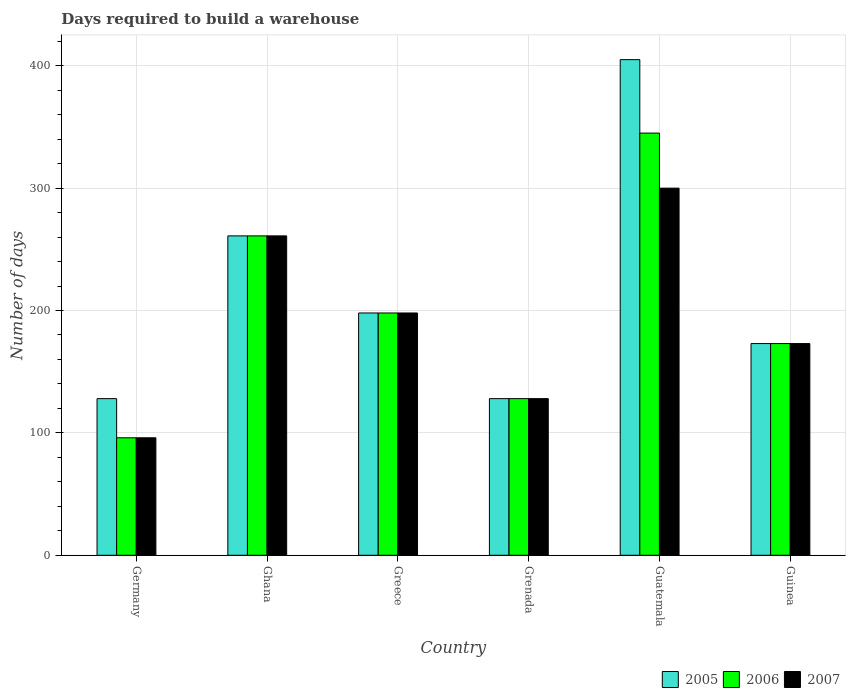How many different coloured bars are there?
Provide a succinct answer. 3. How many groups of bars are there?
Provide a short and direct response. 6. Are the number of bars on each tick of the X-axis equal?
Provide a short and direct response. Yes. How many bars are there on the 3rd tick from the left?
Provide a succinct answer. 3. How many bars are there on the 3rd tick from the right?
Ensure brevity in your answer.  3. What is the label of the 1st group of bars from the left?
Offer a terse response. Germany. In how many cases, is the number of bars for a given country not equal to the number of legend labels?
Ensure brevity in your answer.  0. What is the days required to build a warehouse in in 2006 in Greece?
Provide a succinct answer. 198. Across all countries, what is the maximum days required to build a warehouse in in 2005?
Your answer should be very brief. 405. Across all countries, what is the minimum days required to build a warehouse in in 2006?
Offer a very short reply. 96. In which country was the days required to build a warehouse in in 2006 maximum?
Give a very brief answer. Guatemala. What is the total days required to build a warehouse in in 2005 in the graph?
Make the answer very short. 1293. What is the difference between the days required to build a warehouse in in 2005 in Germany and that in Greece?
Offer a terse response. -70. What is the difference between the days required to build a warehouse in in 2005 in Grenada and the days required to build a warehouse in in 2006 in Greece?
Ensure brevity in your answer.  -70. What is the average days required to build a warehouse in in 2005 per country?
Offer a terse response. 215.5. What is the difference between the days required to build a warehouse in of/in 2007 and days required to build a warehouse in of/in 2006 in Ghana?
Offer a very short reply. 0. What is the ratio of the days required to build a warehouse in in 2006 in Ghana to that in Grenada?
Make the answer very short. 2.04. Is the difference between the days required to build a warehouse in in 2007 in Ghana and Grenada greater than the difference between the days required to build a warehouse in in 2006 in Ghana and Grenada?
Offer a very short reply. No. What is the difference between the highest and the lowest days required to build a warehouse in in 2006?
Your response must be concise. 249. In how many countries, is the days required to build a warehouse in in 2005 greater than the average days required to build a warehouse in in 2005 taken over all countries?
Offer a terse response. 2. Are all the bars in the graph horizontal?
Give a very brief answer. No. What is the difference between two consecutive major ticks on the Y-axis?
Give a very brief answer. 100. Are the values on the major ticks of Y-axis written in scientific E-notation?
Your answer should be compact. No. Does the graph contain any zero values?
Provide a short and direct response. No. How many legend labels are there?
Provide a short and direct response. 3. How are the legend labels stacked?
Your answer should be very brief. Horizontal. What is the title of the graph?
Give a very brief answer. Days required to build a warehouse. What is the label or title of the X-axis?
Make the answer very short. Country. What is the label or title of the Y-axis?
Provide a succinct answer. Number of days. What is the Number of days of 2005 in Germany?
Make the answer very short. 128. What is the Number of days of 2006 in Germany?
Keep it short and to the point. 96. What is the Number of days of 2007 in Germany?
Provide a short and direct response. 96. What is the Number of days of 2005 in Ghana?
Give a very brief answer. 261. What is the Number of days of 2006 in Ghana?
Offer a terse response. 261. What is the Number of days in 2007 in Ghana?
Your response must be concise. 261. What is the Number of days in 2005 in Greece?
Ensure brevity in your answer.  198. What is the Number of days in 2006 in Greece?
Your answer should be very brief. 198. What is the Number of days of 2007 in Greece?
Provide a succinct answer. 198. What is the Number of days of 2005 in Grenada?
Provide a succinct answer. 128. What is the Number of days of 2006 in Grenada?
Your answer should be very brief. 128. What is the Number of days in 2007 in Grenada?
Keep it short and to the point. 128. What is the Number of days in 2005 in Guatemala?
Offer a very short reply. 405. What is the Number of days in 2006 in Guatemala?
Make the answer very short. 345. What is the Number of days of 2007 in Guatemala?
Offer a very short reply. 300. What is the Number of days in 2005 in Guinea?
Make the answer very short. 173. What is the Number of days in 2006 in Guinea?
Provide a succinct answer. 173. What is the Number of days of 2007 in Guinea?
Keep it short and to the point. 173. Across all countries, what is the maximum Number of days in 2005?
Your answer should be compact. 405. Across all countries, what is the maximum Number of days in 2006?
Your response must be concise. 345. Across all countries, what is the maximum Number of days in 2007?
Provide a short and direct response. 300. Across all countries, what is the minimum Number of days in 2005?
Keep it short and to the point. 128. Across all countries, what is the minimum Number of days of 2006?
Keep it short and to the point. 96. Across all countries, what is the minimum Number of days of 2007?
Provide a succinct answer. 96. What is the total Number of days in 2005 in the graph?
Your response must be concise. 1293. What is the total Number of days of 2006 in the graph?
Your answer should be very brief. 1201. What is the total Number of days of 2007 in the graph?
Ensure brevity in your answer.  1156. What is the difference between the Number of days of 2005 in Germany and that in Ghana?
Offer a very short reply. -133. What is the difference between the Number of days of 2006 in Germany and that in Ghana?
Your response must be concise. -165. What is the difference between the Number of days of 2007 in Germany and that in Ghana?
Provide a succinct answer. -165. What is the difference between the Number of days in 2005 in Germany and that in Greece?
Provide a short and direct response. -70. What is the difference between the Number of days of 2006 in Germany and that in Greece?
Make the answer very short. -102. What is the difference between the Number of days of 2007 in Germany and that in Greece?
Provide a succinct answer. -102. What is the difference between the Number of days of 2006 in Germany and that in Grenada?
Provide a short and direct response. -32. What is the difference between the Number of days in 2007 in Germany and that in Grenada?
Offer a very short reply. -32. What is the difference between the Number of days of 2005 in Germany and that in Guatemala?
Provide a succinct answer. -277. What is the difference between the Number of days in 2006 in Germany and that in Guatemala?
Offer a very short reply. -249. What is the difference between the Number of days of 2007 in Germany and that in Guatemala?
Offer a very short reply. -204. What is the difference between the Number of days in 2005 in Germany and that in Guinea?
Your response must be concise. -45. What is the difference between the Number of days of 2006 in Germany and that in Guinea?
Make the answer very short. -77. What is the difference between the Number of days in 2007 in Germany and that in Guinea?
Give a very brief answer. -77. What is the difference between the Number of days of 2005 in Ghana and that in Greece?
Your response must be concise. 63. What is the difference between the Number of days of 2006 in Ghana and that in Greece?
Provide a short and direct response. 63. What is the difference between the Number of days of 2007 in Ghana and that in Greece?
Ensure brevity in your answer.  63. What is the difference between the Number of days of 2005 in Ghana and that in Grenada?
Your response must be concise. 133. What is the difference between the Number of days in 2006 in Ghana and that in Grenada?
Provide a short and direct response. 133. What is the difference between the Number of days of 2007 in Ghana and that in Grenada?
Your response must be concise. 133. What is the difference between the Number of days in 2005 in Ghana and that in Guatemala?
Your answer should be very brief. -144. What is the difference between the Number of days in 2006 in Ghana and that in Guatemala?
Provide a succinct answer. -84. What is the difference between the Number of days of 2007 in Ghana and that in Guatemala?
Offer a very short reply. -39. What is the difference between the Number of days in 2005 in Ghana and that in Guinea?
Provide a short and direct response. 88. What is the difference between the Number of days in 2006 in Ghana and that in Guinea?
Offer a very short reply. 88. What is the difference between the Number of days in 2007 in Ghana and that in Guinea?
Your answer should be very brief. 88. What is the difference between the Number of days of 2006 in Greece and that in Grenada?
Give a very brief answer. 70. What is the difference between the Number of days of 2007 in Greece and that in Grenada?
Provide a succinct answer. 70. What is the difference between the Number of days in 2005 in Greece and that in Guatemala?
Give a very brief answer. -207. What is the difference between the Number of days of 2006 in Greece and that in Guatemala?
Offer a very short reply. -147. What is the difference between the Number of days in 2007 in Greece and that in Guatemala?
Keep it short and to the point. -102. What is the difference between the Number of days of 2007 in Greece and that in Guinea?
Your answer should be compact. 25. What is the difference between the Number of days in 2005 in Grenada and that in Guatemala?
Provide a succinct answer. -277. What is the difference between the Number of days of 2006 in Grenada and that in Guatemala?
Your response must be concise. -217. What is the difference between the Number of days in 2007 in Grenada and that in Guatemala?
Provide a succinct answer. -172. What is the difference between the Number of days of 2005 in Grenada and that in Guinea?
Your response must be concise. -45. What is the difference between the Number of days in 2006 in Grenada and that in Guinea?
Ensure brevity in your answer.  -45. What is the difference between the Number of days of 2007 in Grenada and that in Guinea?
Keep it short and to the point. -45. What is the difference between the Number of days in 2005 in Guatemala and that in Guinea?
Provide a short and direct response. 232. What is the difference between the Number of days in 2006 in Guatemala and that in Guinea?
Give a very brief answer. 172. What is the difference between the Number of days of 2007 in Guatemala and that in Guinea?
Your answer should be compact. 127. What is the difference between the Number of days of 2005 in Germany and the Number of days of 2006 in Ghana?
Your answer should be very brief. -133. What is the difference between the Number of days in 2005 in Germany and the Number of days in 2007 in Ghana?
Keep it short and to the point. -133. What is the difference between the Number of days in 2006 in Germany and the Number of days in 2007 in Ghana?
Give a very brief answer. -165. What is the difference between the Number of days of 2005 in Germany and the Number of days of 2006 in Greece?
Your answer should be compact. -70. What is the difference between the Number of days in 2005 in Germany and the Number of days in 2007 in Greece?
Provide a succinct answer. -70. What is the difference between the Number of days of 2006 in Germany and the Number of days of 2007 in Greece?
Give a very brief answer. -102. What is the difference between the Number of days in 2006 in Germany and the Number of days in 2007 in Grenada?
Ensure brevity in your answer.  -32. What is the difference between the Number of days in 2005 in Germany and the Number of days in 2006 in Guatemala?
Provide a short and direct response. -217. What is the difference between the Number of days of 2005 in Germany and the Number of days of 2007 in Guatemala?
Your answer should be very brief. -172. What is the difference between the Number of days of 2006 in Germany and the Number of days of 2007 in Guatemala?
Give a very brief answer. -204. What is the difference between the Number of days in 2005 in Germany and the Number of days in 2006 in Guinea?
Ensure brevity in your answer.  -45. What is the difference between the Number of days of 2005 in Germany and the Number of days of 2007 in Guinea?
Offer a terse response. -45. What is the difference between the Number of days of 2006 in Germany and the Number of days of 2007 in Guinea?
Make the answer very short. -77. What is the difference between the Number of days in 2005 in Ghana and the Number of days in 2006 in Greece?
Ensure brevity in your answer.  63. What is the difference between the Number of days in 2005 in Ghana and the Number of days in 2007 in Greece?
Ensure brevity in your answer.  63. What is the difference between the Number of days in 2005 in Ghana and the Number of days in 2006 in Grenada?
Provide a succinct answer. 133. What is the difference between the Number of days of 2005 in Ghana and the Number of days of 2007 in Grenada?
Your response must be concise. 133. What is the difference between the Number of days of 2006 in Ghana and the Number of days of 2007 in Grenada?
Give a very brief answer. 133. What is the difference between the Number of days of 2005 in Ghana and the Number of days of 2006 in Guatemala?
Keep it short and to the point. -84. What is the difference between the Number of days in 2005 in Ghana and the Number of days in 2007 in Guatemala?
Offer a terse response. -39. What is the difference between the Number of days in 2006 in Ghana and the Number of days in 2007 in Guatemala?
Offer a terse response. -39. What is the difference between the Number of days of 2006 in Ghana and the Number of days of 2007 in Guinea?
Make the answer very short. 88. What is the difference between the Number of days of 2006 in Greece and the Number of days of 2007 in Grenada?
Keep it short and to the point. 70. What is the difference between the Number of days of 2005 in Greece and the Number of days of 2006 in Guatemala?
Your answer should be compact. -147. What is the difference between the Number of days of 2005 in Greece and the Number of days of 2007 in Guatemala?
Offer a terse response. -102. What is the difference between the Number of days in 2006 in Greece and the Number of days in 2007 in Guatemala?
Your response must be concise. -102. What is the difference between the Number of days of 2005 in Greece and the Number of days of 2006 in Guinea?
Ensure brevity in your answer.  25. What is the difference between the Number of days of 2005 in Greece and the Number of days of 2007 in Guinea?
Your answer should be very brief. 25. What is the difference between the Number of days of 2005 in Grenada and the Number of days of 2006 in Guatemala?
Your answer should be very brief. -217. What is the difference between the Number of days of 2005 in Grenada and the Number of days of 2007 in Guatemala?
Make the answer very short. -172. What is the difference between the Number of days of 2006 in Grenada and the Number of days of 2007 in Guatemala?
Provide a short and direct response. -172. What is the difference between the Number of days of 2005 in Grenada and the Number of days of 2006 in Guinea?
Keep it short and to the point. -45. What is the difference between the Number of days in 2005 in Grenada and the Number of days in 2007 in Guinea?
Offer a terse response. -45. What is the difference between the Number of days of 2006 in Grenada and the Number of days of 2007 in Guinea?
Your answer should be very brief. -45. What is the difference between the Number of days of 2005 in Guatemala and the Number of days of 2006 in Guinea?
Your answer should be compact. 232. What is the difference between the Number of days in 2005 in Guatemala and the Number of days in 2007 in Guinea?
Ensure brevity in your answer.  232. What is the difference between the Number of days of 2006 in Guatemala and the Number of days of 2007 in Guinea?
Your answer should be very brief. 172. What is the average Number of days of 2005 per country?
Keep it short and to the point. 215.5. What is the average Number of days of 2006 per country?
Offer a very short reply. 200.17. What is the average Number of days of 2007 per country?
Offer a very short reply. 192.67. What is the difference between the Number of days in 2006 and Number of days in 2007 in Germany?
Make the answer very short. 0. What is the difference between the Number of days of 2005 and Number of days of 2006 in Ghana?
Provide a succinct answer. 0. What is the difference between the Number of days of 2005 and Number of days of 2007 in Ghana?
Keep it short and to the point. 0. What is the difference between the Number of days in 2006 and Number of days in 2007 in Ghana?
Your response must be concise. 0. What is the difference between the Number of days in 2005 and Number of days in 2006 in Greece?
Your answer should be very brief. 0. What is the difference between the Number of days of 2006 and Number of days of 2007 in Greece?
Your answer should be compact. 0. What is the difference between the Number of days in 2005 and Number of days in 2007 in Grenada?
Ensure brevity in your answer.  0. What is the difference between the Number of days of 2005 and Number of days of 2007 in Guatemala?
Offer a very short reply. 105. What is the difference between the Number of days of 2006 and Number of days of 2007 in Guatemala?
Your response must be concise. 45. What is the difference between the Number of days of 2005 and Number of days of 2007 in Guinea?
Keep it short and to the point. 0. What is the ratio of the Number of days in 2005 in Germany to that in Ghana?
Your answer should be very brief. 0.49. What is the ratio of the Number of days of 2006 in Germany to that in Ghana?
Give a very brief answer. 0.37. What is the ratio of the Number of days in 2007 in Germany to that in Ghana?
Provide a short and direct response. 0.37. What is the ratio of the Number of days of 2005 in Germany to that in Greece?
Your answer should be very brief. 0.65. What is the ratio of the Number of days of 2006 in Germany to that in Greece?
Provide a succinct answer. 0.48. What is the ratio of the Number of days in 2007 in Germany to that in Greece?
Your answer should be very brief. 0.48. What is the ratio of the Number of days of 2005 in Germany to that in Grenada?
Ensure brevity in your answer.  1. What is the ratio of the Number of days of 2005 in Germany to that in Guatemala?
Offer a very short reply. 0.32. What is the ratio of the Number of days of 2006 in Germany to that in Guatemala?
Your answer should be compact. 0.28. What is the ratio of the Number of days in 2007 in Germany to that in Guatemala?
Your response must be concise. 0.32. What is the ratio of the Number of days of 2005 in Germany to that in Guinea?
Keep it short and to the point. 0.74. What is the ratio of the Number of days of 2006 in Germany to that in Guinea?
Provide a short and direct response. 0.55. What is the ratio of the Number of days in 2007 in Germany to that in Guinea?
Ensure brevity in your answer.  0.55. What is the ratio of the Number of days of 2005 in Ghana to that in Greece?
Keep it short and to the point. 1.32. What is the ratio of the Number of days of 2006 in Ghana to that in Greece?
Offer a very short reply. 1.32. What is the ratio of the Number of days in 2007 in Ghana to that in Greece?
Ensure brevity in your answer.  1.32. What is the ratio of the Number of days of 2005 in Ghana to that in Grenada?
Keep it short and to the point. 2.04. What is the ratio of the Number of days of 2006 in Ghana to that in Grenada?
Your answer should be compact. 2.04. What is the ratio of the Number of days of 2007 in Ghana to that in Grenada?
Provide a succinct answer. 2.04. What is the ratio of the Number of days of 2005 in Ghana to that in Guatemala?
Offer a terse response. 0.64. What is the ratio of the Number of days in 2006 in Ghana to that in Guatemala?
Offer a very short reply. 0.76. What is the ratio of the Number of days of 2007 in Ghana to that in Guatemala?
Your answer should be very brief. 0.87. What is the ratio of the Number of days of 2005 in Ghana to that in Guinea?
Give a very brief answer. 1.51. What is the ratio of the Number of days in 2006 in Ghana to that in Guinea?
Make the answer very short. 1.51. What is the ratio of the Number of days of 2007 in Ghana to that in Guinea?
Provide a succinct answer. 1.51. What is the ratio of the Number of days in 2005 in Greece to that in Grenada?
Keep it short and to the point. 1.55. What is the ratio of the Number of days of 2006 in Greece to that in Grenada?
Your answer should be very brief. 1.55. What is the ratio of the Number of days of 2007 in Greece to that in Grenada?
Offer a very short reply. 1.55. What is the ratio of the Number of days of 2005 in Greece to that in Guatemala?
Give a very brief answer. 0.49. What is the ratio of the Number of days of 2006 in Greece to that in Guatemala?
Your response must be concise. 0.57. What is the ratio of the Number of days of 2007 in Greece to that in Guatemala?
Your answer should be very brief. 0.66. What is the ratio of the Number of days of 2005 in Greece to that in Guinea?
Offer a very short reply. 1.14. What is the ratio of the Number of days of 2006 in Greece to that in Guinea?
Give a very brief answer. 1.14. What is the ratio of the Number of days of 2007 in Greece to that in Guinea?
Ensure brevity in your answer.  1.14. What is the ratio of the Number of days in 2005 in Grenada to that in Guatemala?
Your response must be concise. 0.32. What is the ratio of the Number of days in 2006 in Grenada to that in Guatemala?
Ensure brevity in your answer.  0.37. What is the ratio of the Number of days of 2007 in Grenada to that in Guatemala?
Provide a succinct answer. 0.43. What is the ratio of the Number of days in 2005 in Grenada to that in Guinea?
Make the answer very short. 0.74. What is the ratio of the Number of days in 2006 in Grenada to that in Guinea?
Your answer should be compact. 0.74. What is the ratio of the Number of days of 2007 in Grenada to that in Guinea?
Provide a short and direct response. 0.74. What is the ratio of the Number of days in 2005 in Guatemala to that in Guinea?
Ensure brevity in your answer.  2.34. What is the ratio of the Number of days of 2006 in Guatemala to that in Guinea?
Provide a short and direct response. 1.99. What is the ratio of the Number of days in 2007 in Guatemala to that in Guinea?
Your answer should be very brief. 1.73. What is the difference between the highest and the second highest Number of days of 2005?
Give a very brief answer. 144. What is the difference between the highest and the second highest Number of days of 2006?
Keep it short and to the point. 84. What is the difference between the highest and the lowest Number of days in 2005?
Keep it short and to the point. 277. What is the difference between the highest and the lowest Number of days in 2006?
Your response must be concise. 249. What is the difference between the highest and the lowest Number of days of 2007?
Offer a very short reply. 204. 